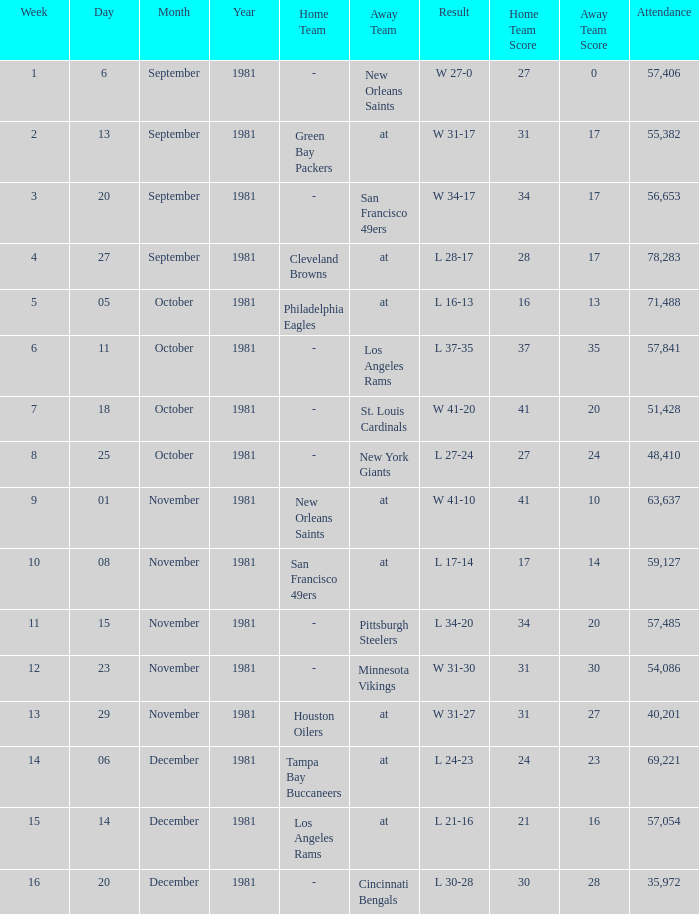On what date did the team play againt the New Orleans Saints? September 6, 1981. 